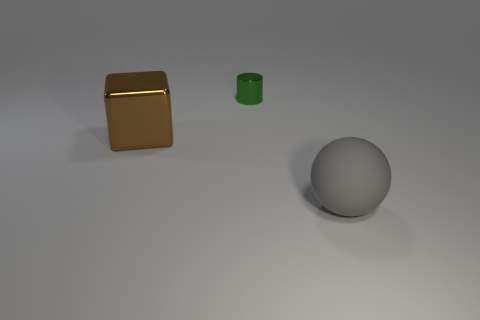Is there a gray thing?
Offer a terse response. Yes. Does the large brown cube have the same material as the object that is to the right of the tiny green shiny object?
Make the answer very short. No. What is the material of the thing that is the same size as the brown block?
Ensure brevity in your answer.  Rubber. Is there a green cylinder made of the same material as the brown cube?
Your answer should be compact. Yes. There is a large object that is on the left side of the large gray object that is on the right side of the large metallic thing; is there a brown metal thing to the right of it?
Your response must be concise. No. What is the shape of the other thing that is the same size as the rubber thing?
Offer a terse response. Cube. There is a thing that is to the left of the tiny green metal object; does it have the same size as the object that is in front of the big brown metal thing?
Your answer should be very brief. Yes. What number of brown things are there?
Your answer should be very brief. 1. What is the size of the object to the left of the object behind the big thing that is behind the large matte ball?
Provide a short and direct response. Large. Is the large ball the same color as the tiny cylinder?
Make the answer very short. No. 